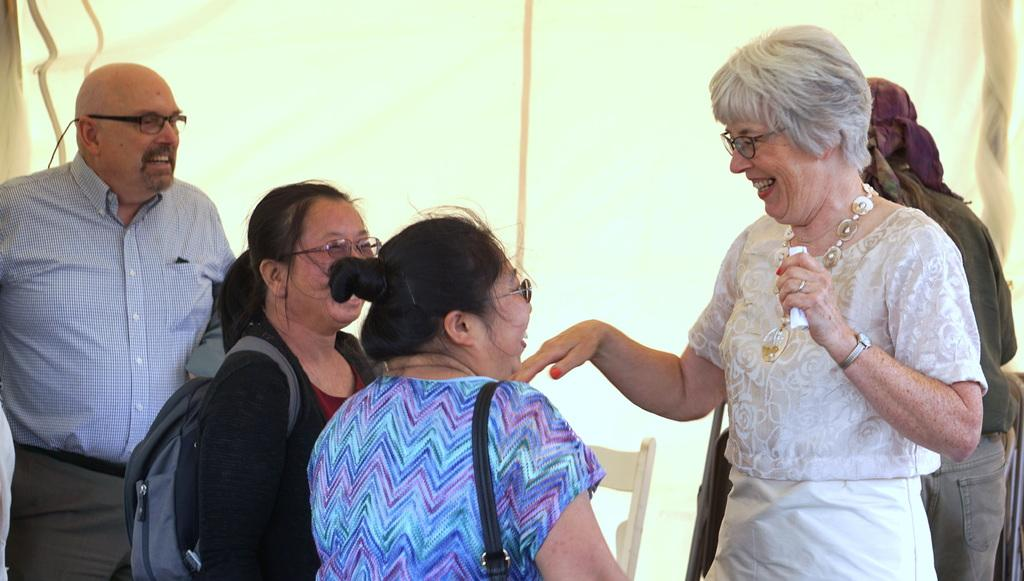How many people are in the image? There is a group of people in the image, but the exact number cannot be determined from the provided facts. What is located behind the people in the image? There is a chair and an object visible behind the people in the image. Can you describe the object behind the people? Unfortunately, the object behind the people cannot be described in detail based on the provided facts. How many mice are crawling on the chair behind the people in the image? There is no mention of mice in the provided facts, so it cannot be determined if any mice are present in the image. 